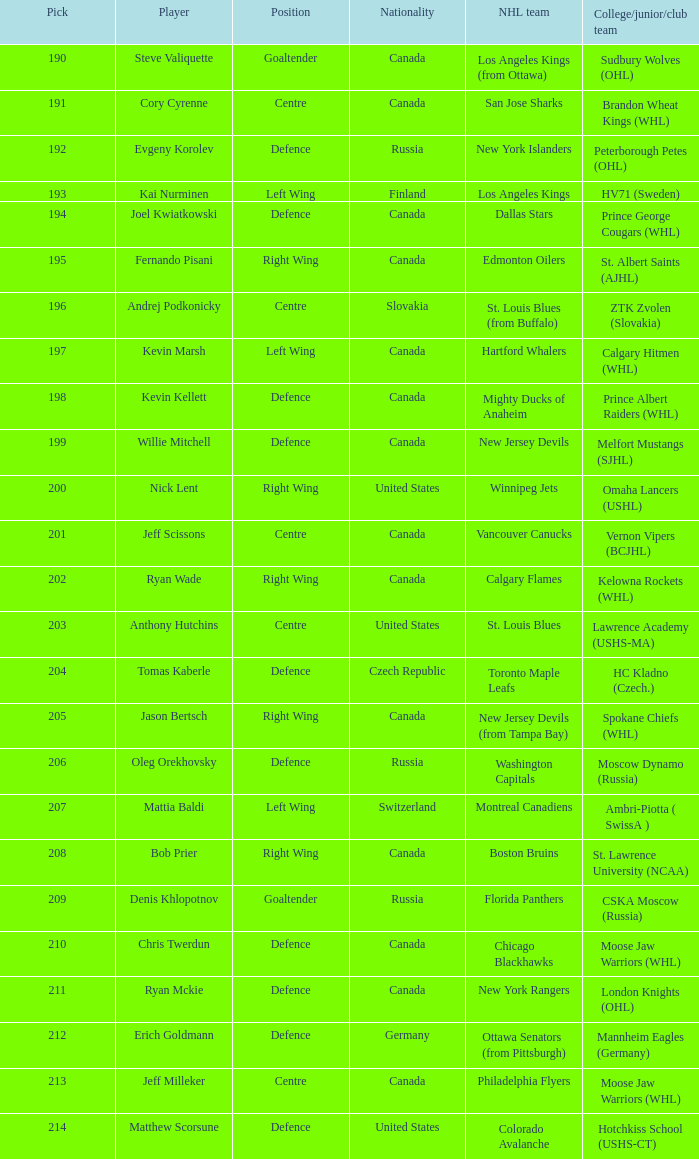Name the number of nationalities for ryan mckie 1.0. 